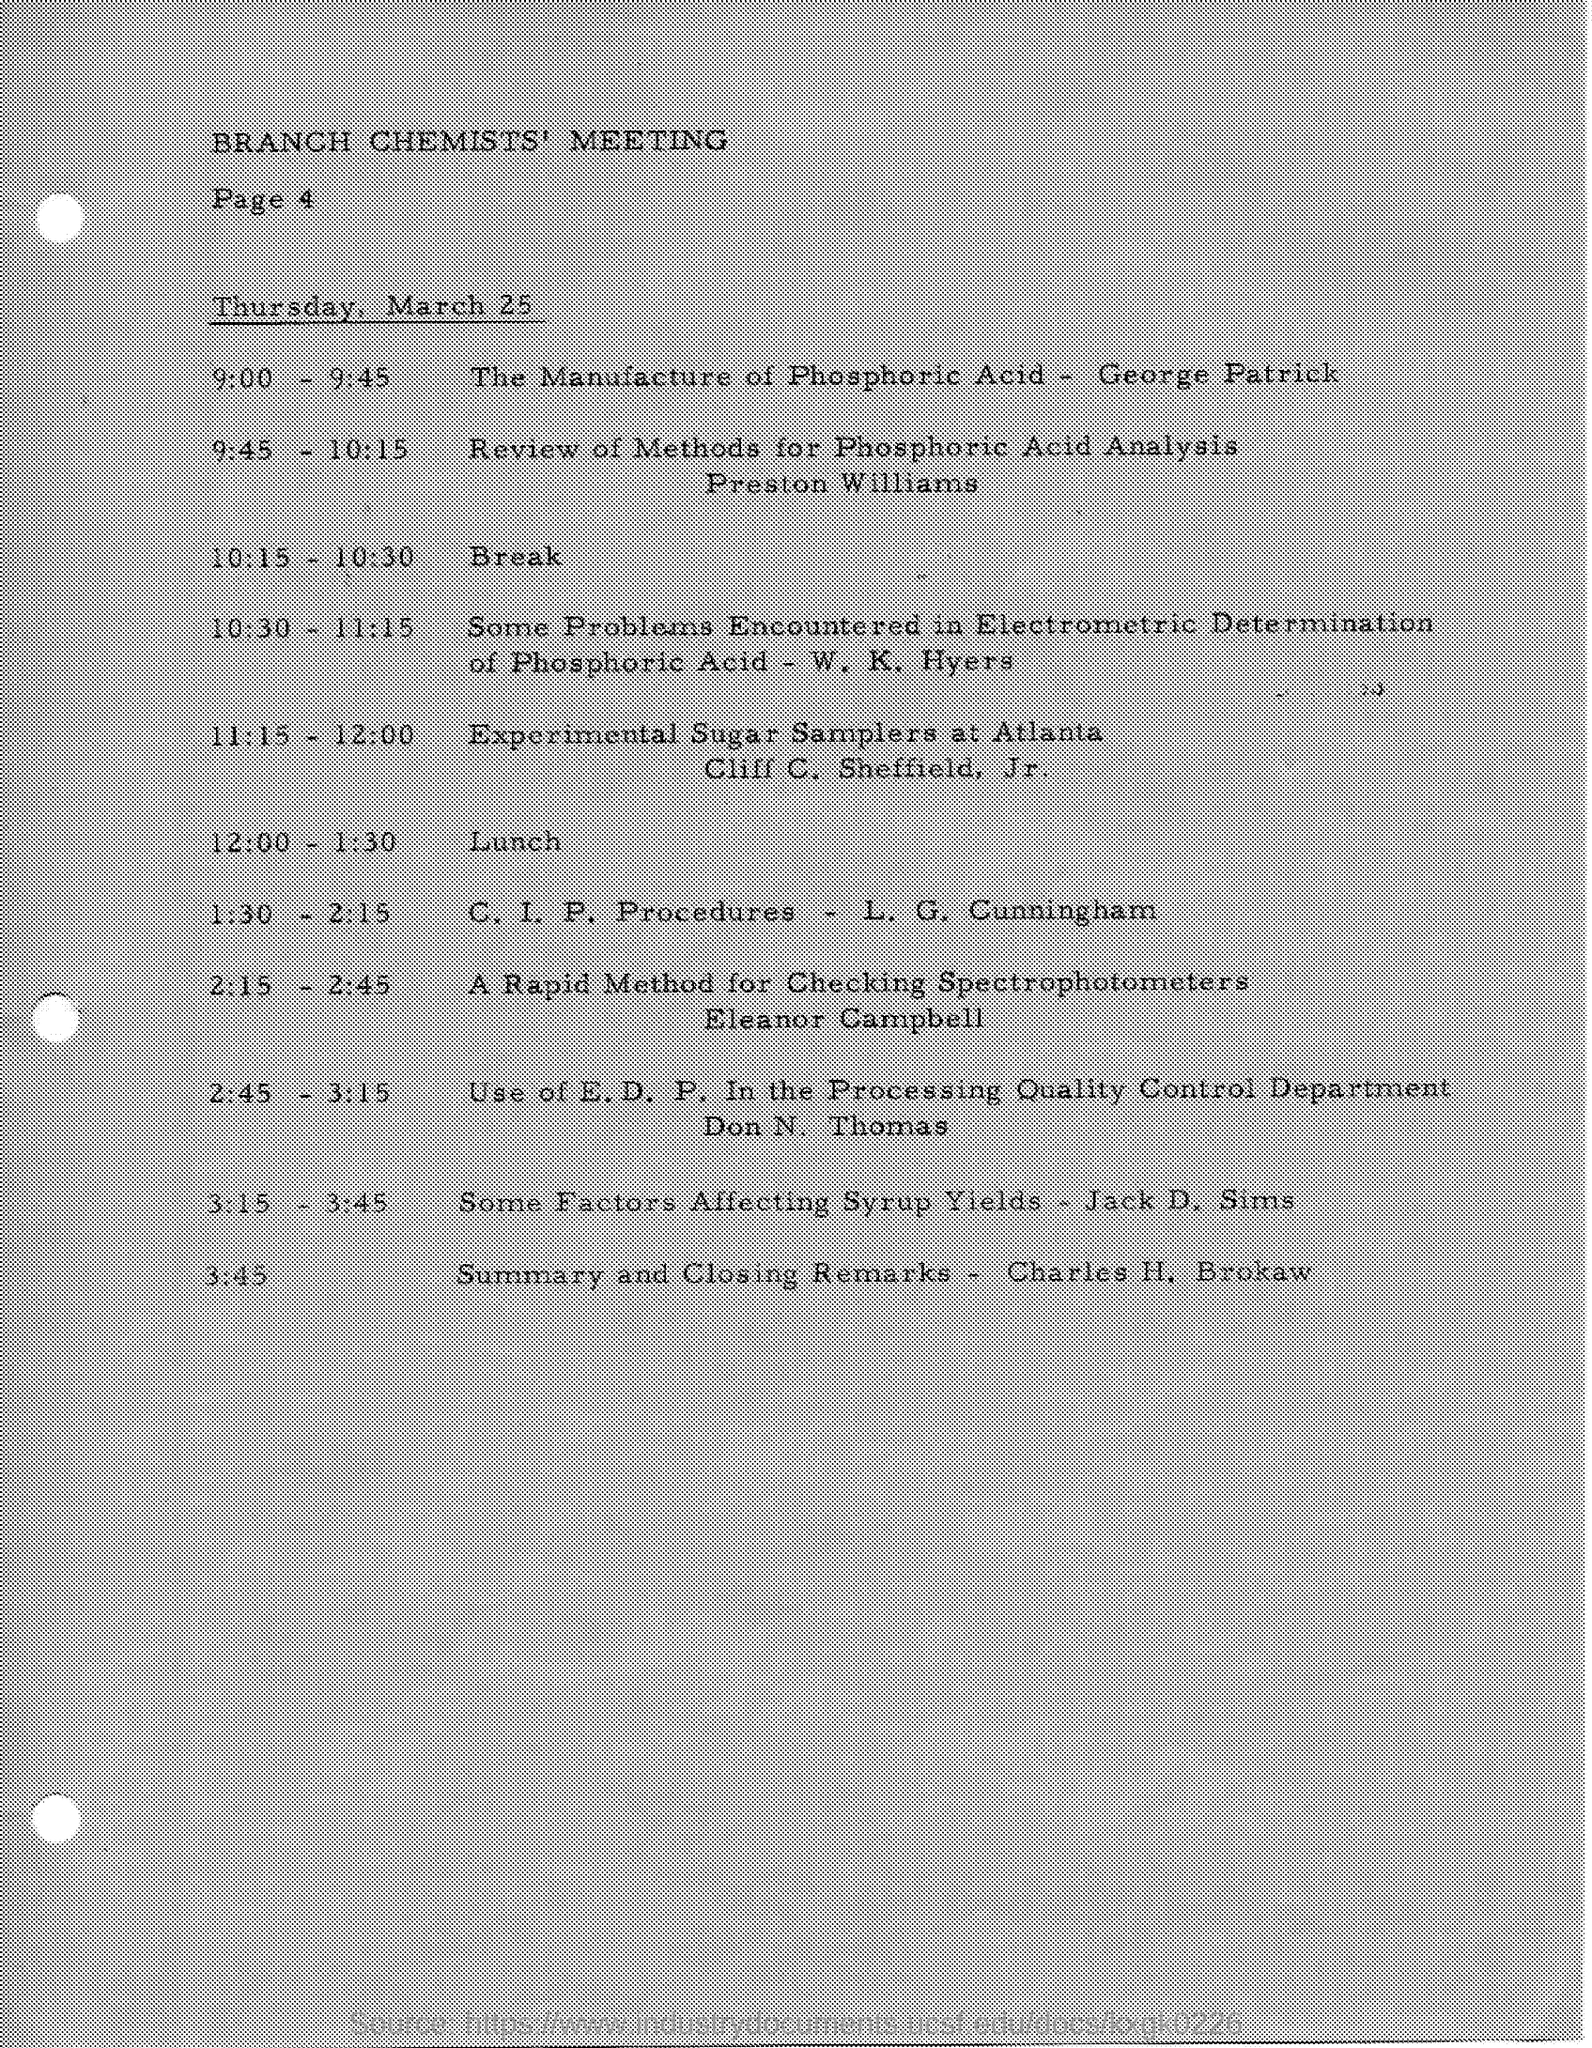List a handful of essential elements in this visual. The closing time was 3:45. The person who provided a summary is Charles H. Brokaw. Preston Williams discussed the review methods for phosphoric acid analysis. Page 4 contains information about the Branch Chemists' Meeting. 